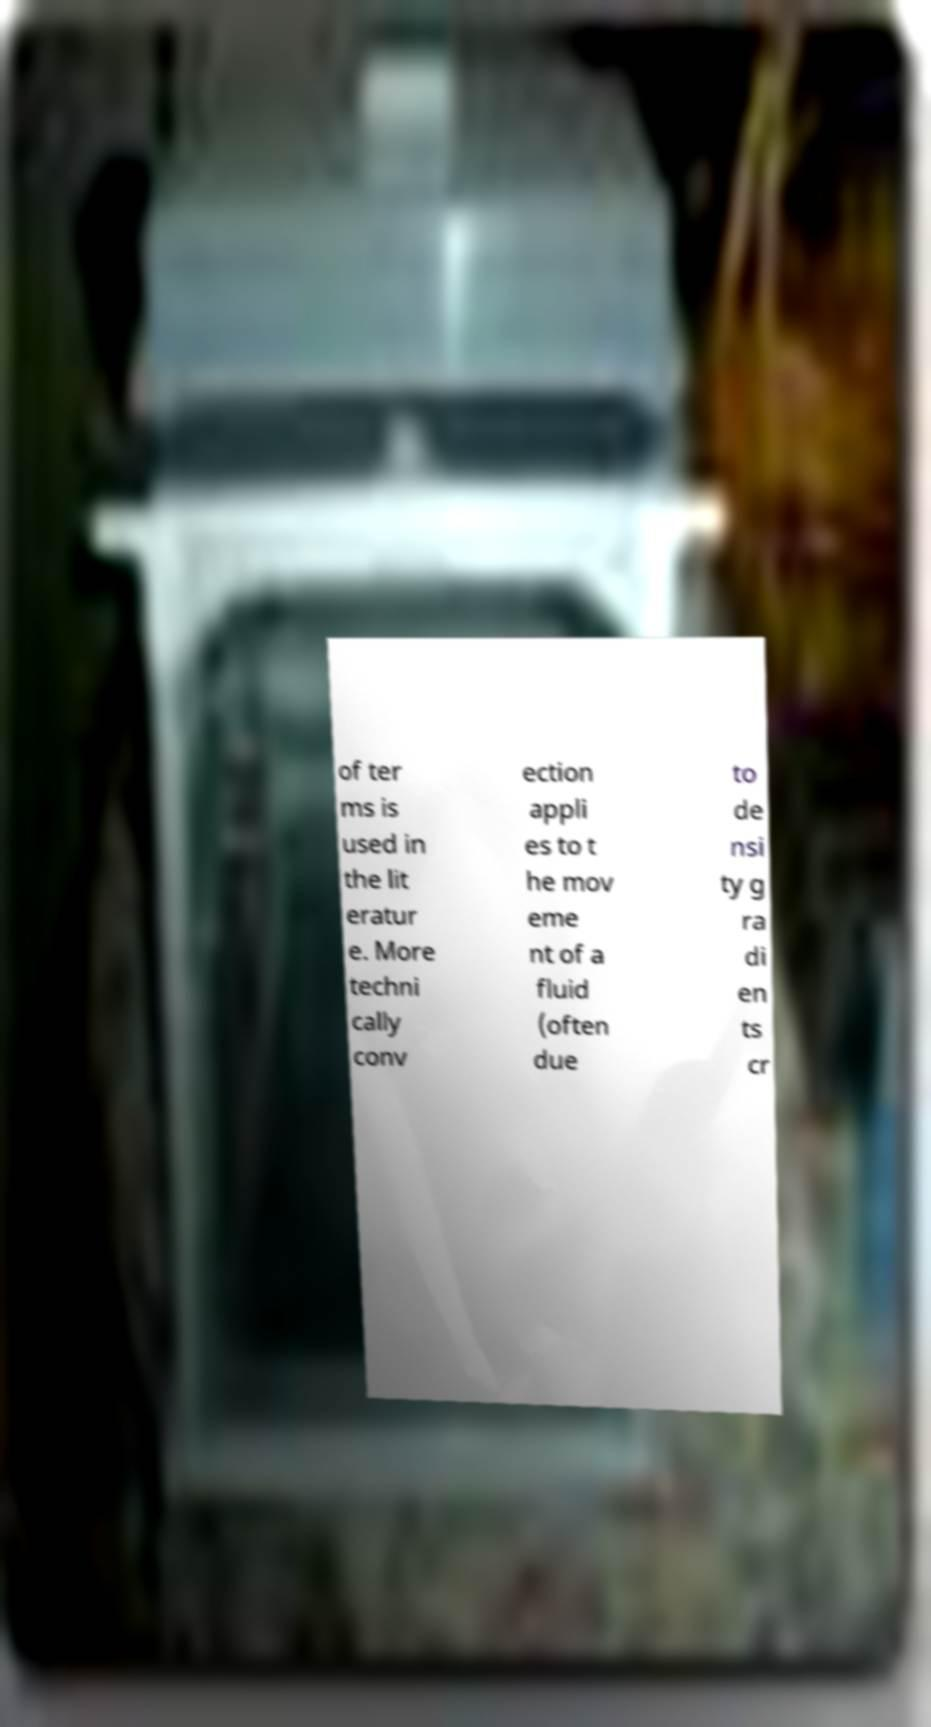There's text embedded in this image that I need extracted. Can you transcribe it verbatim? of ter ms is used in the lit eratur e. More techni cally conv ection appli es to t he mov eme nt of a fluid (often due to de nsi ty g ra di en ts cr 